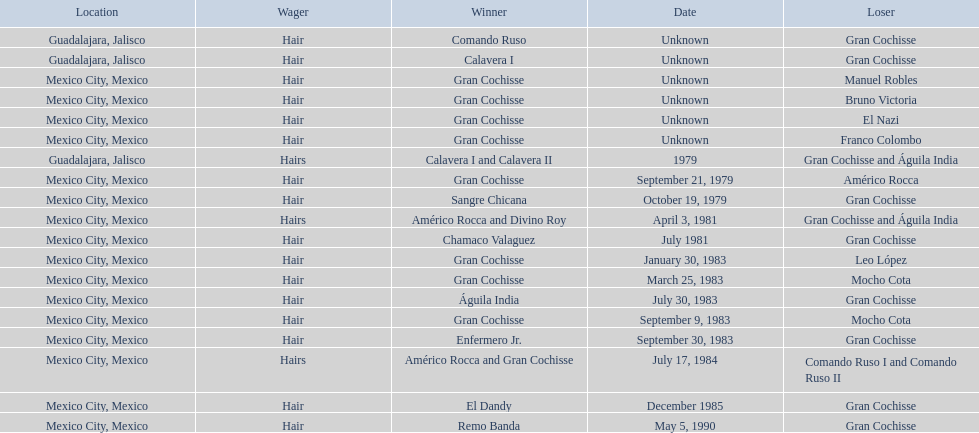How many times has the wager been hair? 16. 